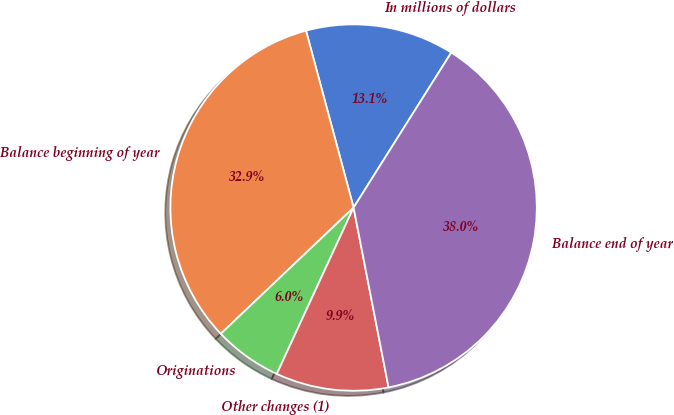Convert chart to OTSL. <chart><loc_0><loc_0><loc_500><loc_500><pie_chart><fcel>In millions of dollars<fcel>Balance beginning of year<fcel>Originations<fcel>Other changes (1)<fcel>Balance end of year<nl><fcel>13.13%<fcel>32.91%<fcel>6.02%<fcel>9.94%<fcel>37.99%<nl></chart> 